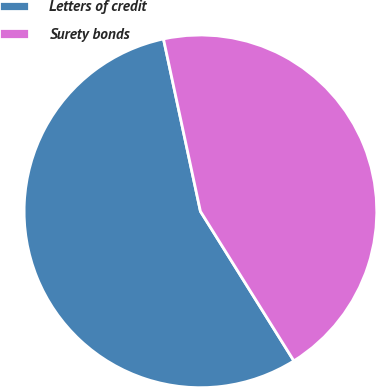Convert chart to OTSL. <chart><loc_0><loc_0><loc_500><loc_500><pie_chart><fcel>Letters of credit<fcel>Surety bonds<nl><fcel>55.53%<fcel>44.47%<nl></chart> 